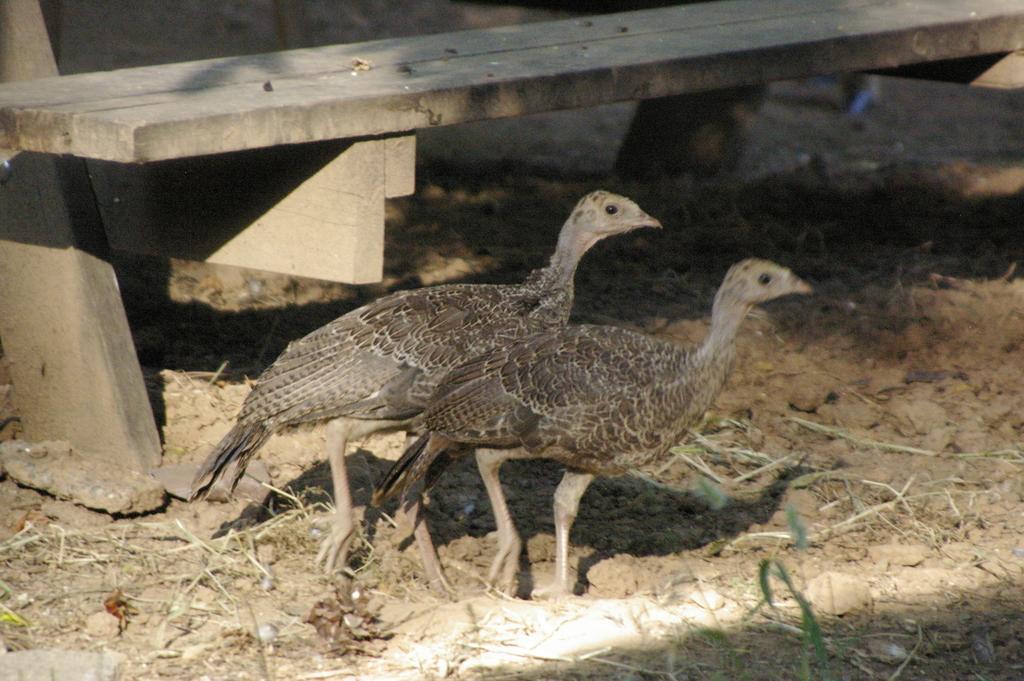Can you describe this image briefly? In the center of the image there are hens. In the background there is a bench. At the bottom we can see grass. 